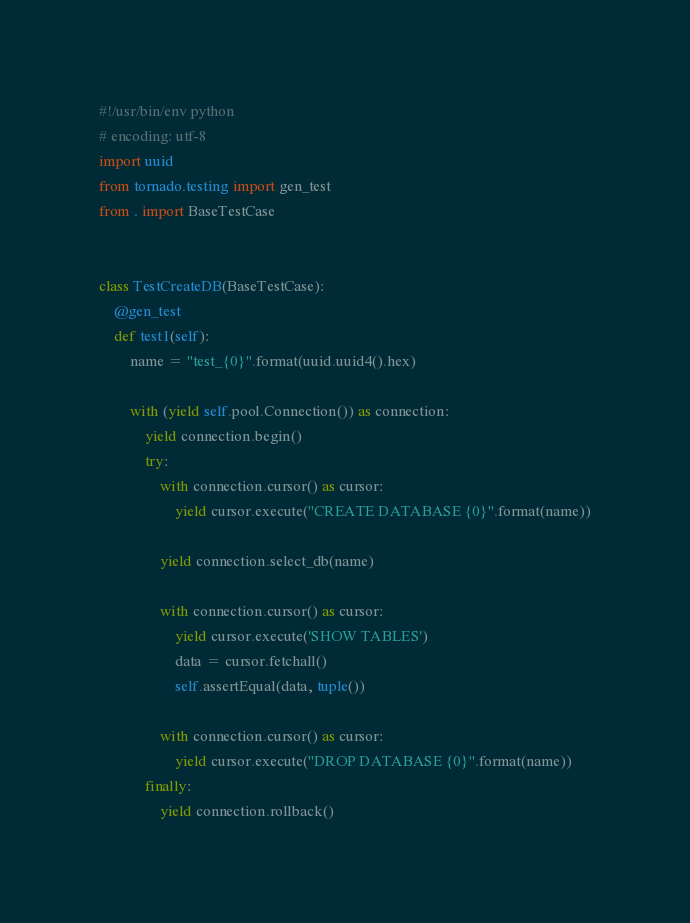Convert code to text. <code><loc_0><loc_0><loc_500><loc_500><_Python_>#!/usr/bin/env python
# encoding: utf-8
import uuid
from tornado.testing import gen_test
from . import BaseTestCase


class TestCreateDB(BaseTestCase):
    @gen_test
    def test1(self):
        name = "test_{0}".format(uuid.uuid4().hex)

        with (yield self.pool.Connection()) as connection:
            yield connection.begin()
            try:
                with connection.cursor() as cursor:
                    yield cursor.execute("CREATE DATABASE {0}".format(name))

                yield connection.select_db(name)

                with connection.cursor() as cursor:
                    yield cursor.execute('SHOW TABLES')
                    data = cursor.fetchall()
                    self.assertEqual(data, tuple())

                with connection.cursor() as cursor:
                    yield cursor.execute("DROP DATABASE {0}".format(name))
            finally:
                yield connection.rollback()
</code> 